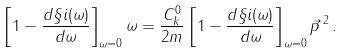Convert formula to latex. <formula><loc_0><loc_0><loc_500><loc_500>\left [ 1 - \frac { d \S i ( \omega ) } { d \omega } \right ] _ { \omega = 0 } \omega = \frac { C _ { k } ^ { 0 } } { 2 m } \left [ 1 - \frac { d \S i ( \omega ) } { d \omega } \right ] _ { \omega = 0 } \vec { p } \, ^ { 2 } \, .</formula> 